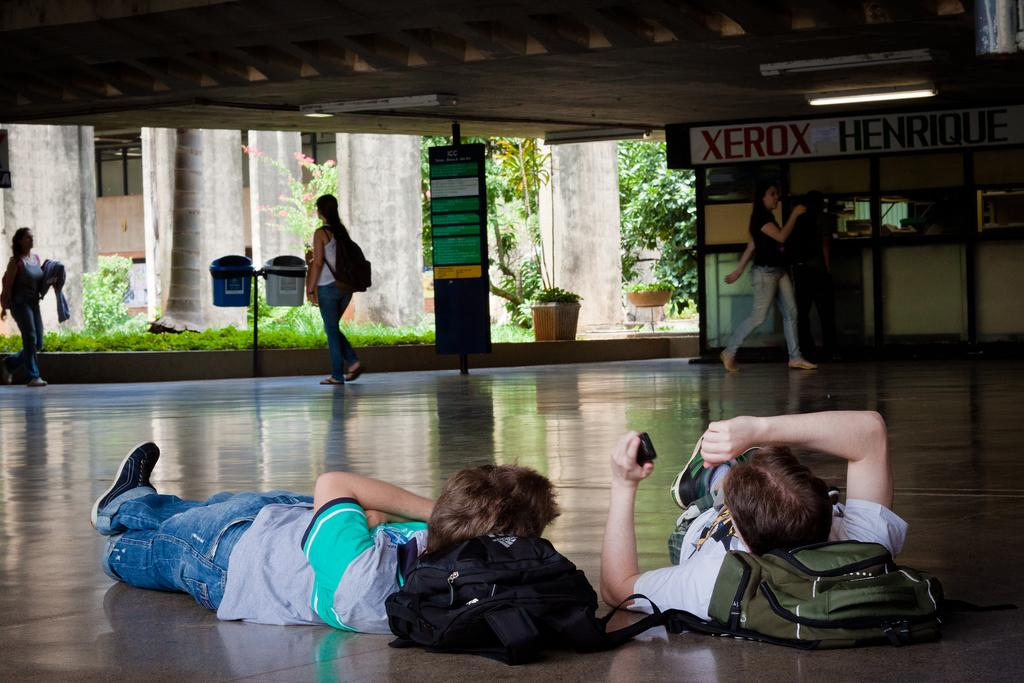How many people are in the image? There is a group of people in the image. What are some of the people in the group doing? Some people in the group are laying on the floor, while others are walking. Where is the throne located in the image? There is no throne present in the image. What color is the balloon being held by one of the people in the image? There is no balloon present in the image. 